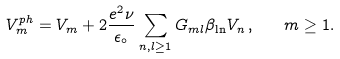<formula> <loc_0><loc_0><loc_500><loc_500>V ^ { p h } _ { m } = V _ { m } + 2 \frac { e ^ { 2 } \nu } { \epsilon _ { \circ } } \sum _ { n , l \geq 1 } G _ { m l } \beta _ { \ln } V _ { n } \, , \quad m \geq 1 .</formula> 